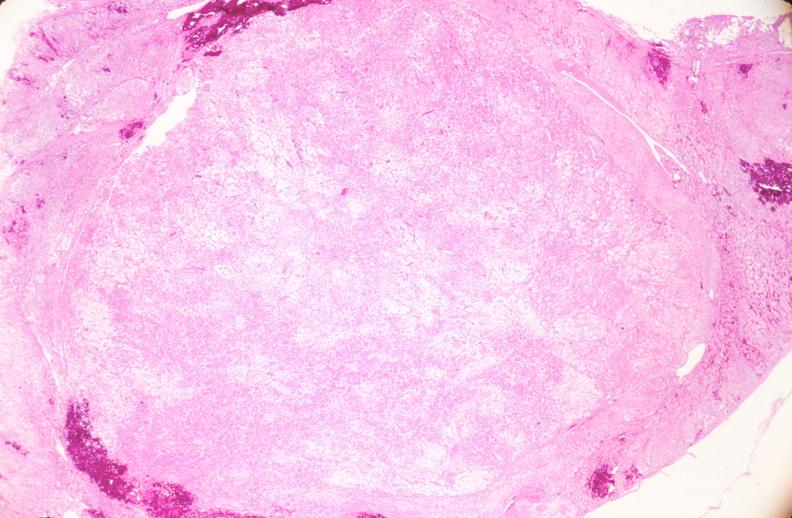what is present?
Answer the question using a single word or phrase. Female reproductive 